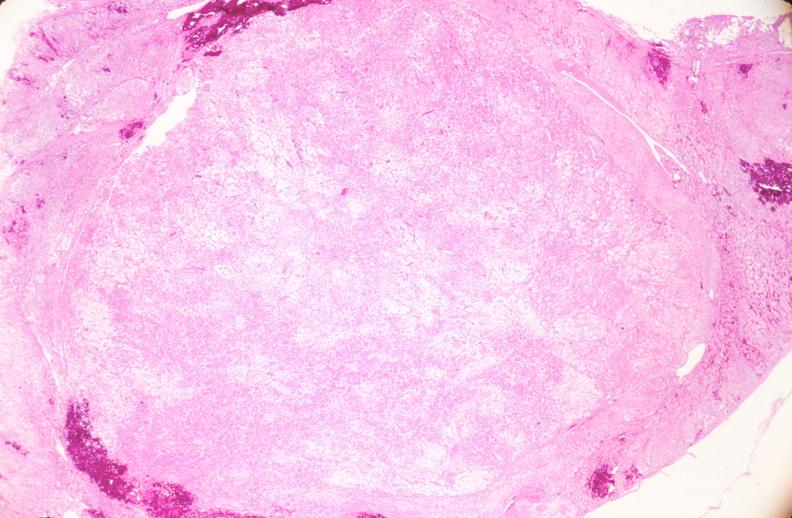what is present?
Answer the question using a single word or phrase. Female reproductive 